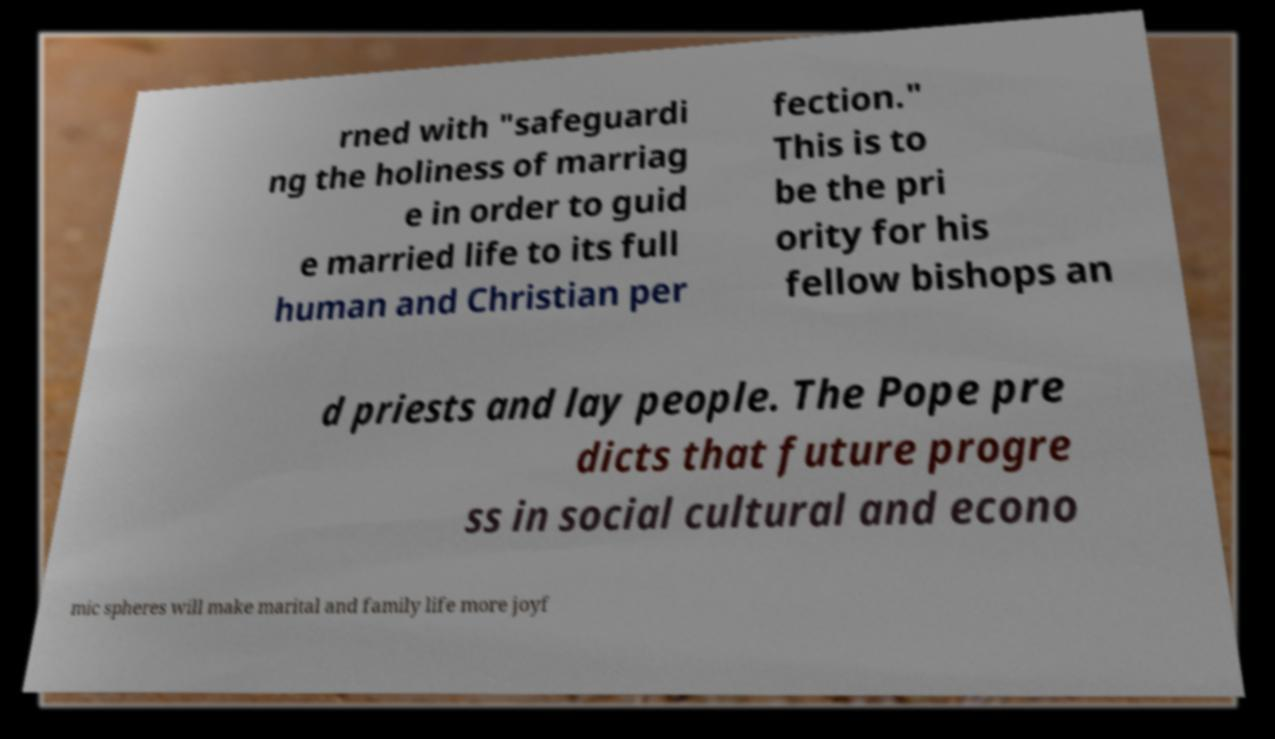There's text embedded in this image that I need extracted. Can you transcribe it verbatim? rned with "safeguardi ng the holiness of marriag e in order to guid e married life to its full human and Christian per fection." This is to be the pri ority for his fellow bishops an d priests and lay people. The Pope pre dicts that future progre ss in social cultural and econo mic spheres will make marital and family life more joyf 